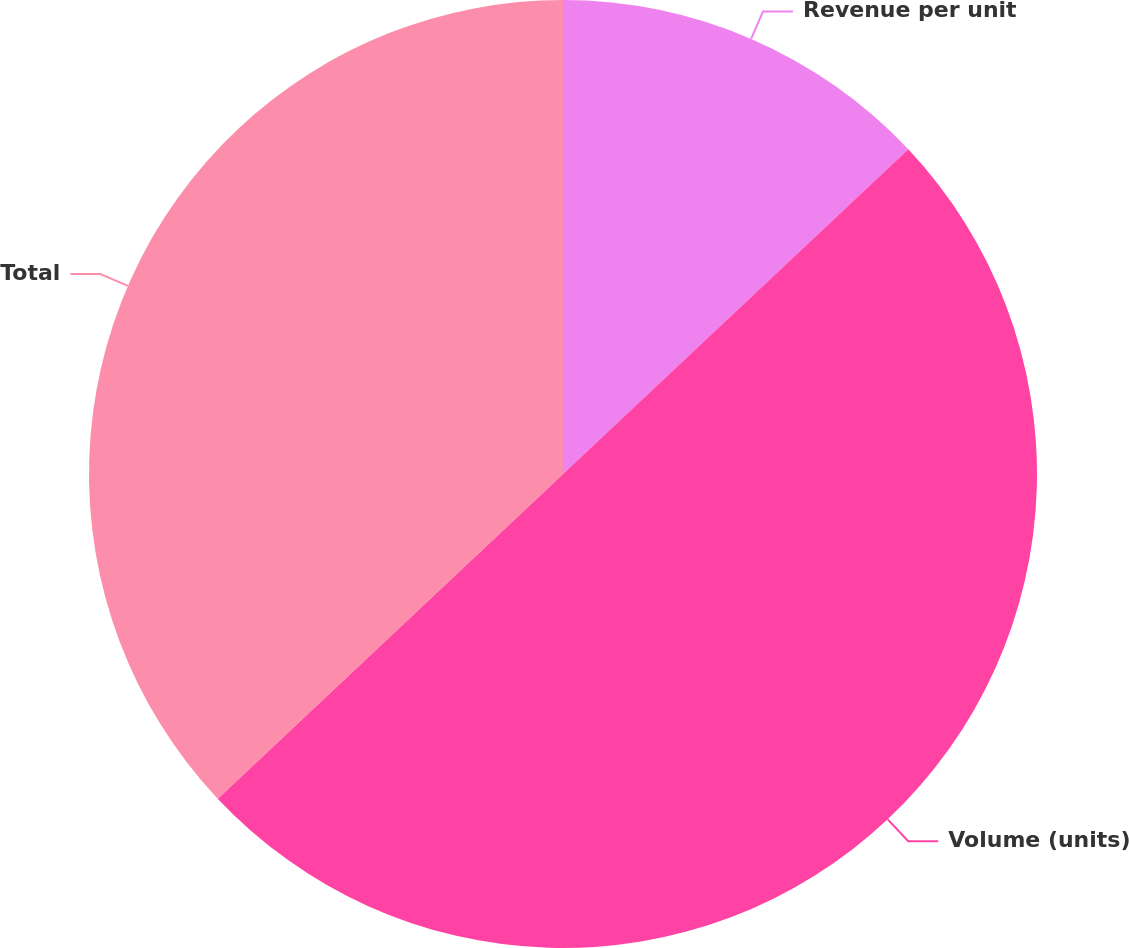Convert chart to OTSL. <chart><loc_0><loc_0><loc_500><loc_500><pie_chart><fcel>Revenue per unit<fcel>Volume (units)<fcel>Total<nl><fcel>12.99%<fcel>50.0%<fcel>37.01%<nl></chart> 